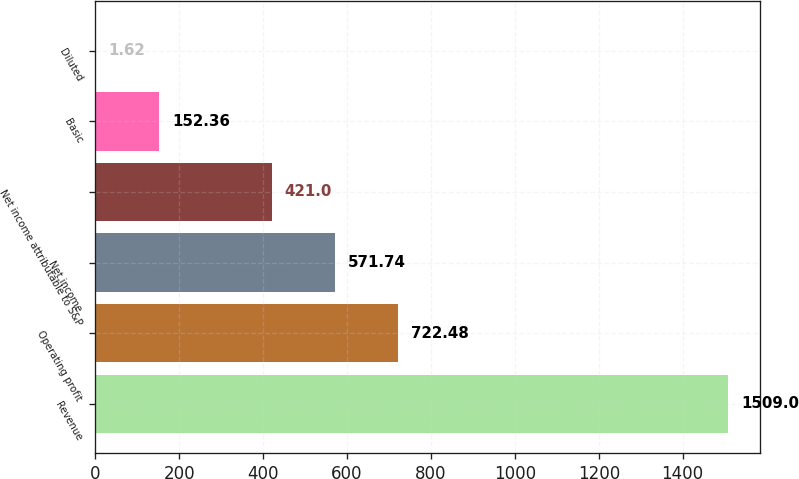Convert chart. <chart><loc_0><loc_0><loc_500><loc_500><bar_chart><fcel>Revenue<fcel>Operating profit<fcel>Net income<fcel>Net income attributable to S&P<fcel>Basic<fcel>Diluted<nl><fcel>1509<fcel>722.48<fcel>571.74<fcel>421<fcel>152.36<fcel>1.62<nl></chart> 